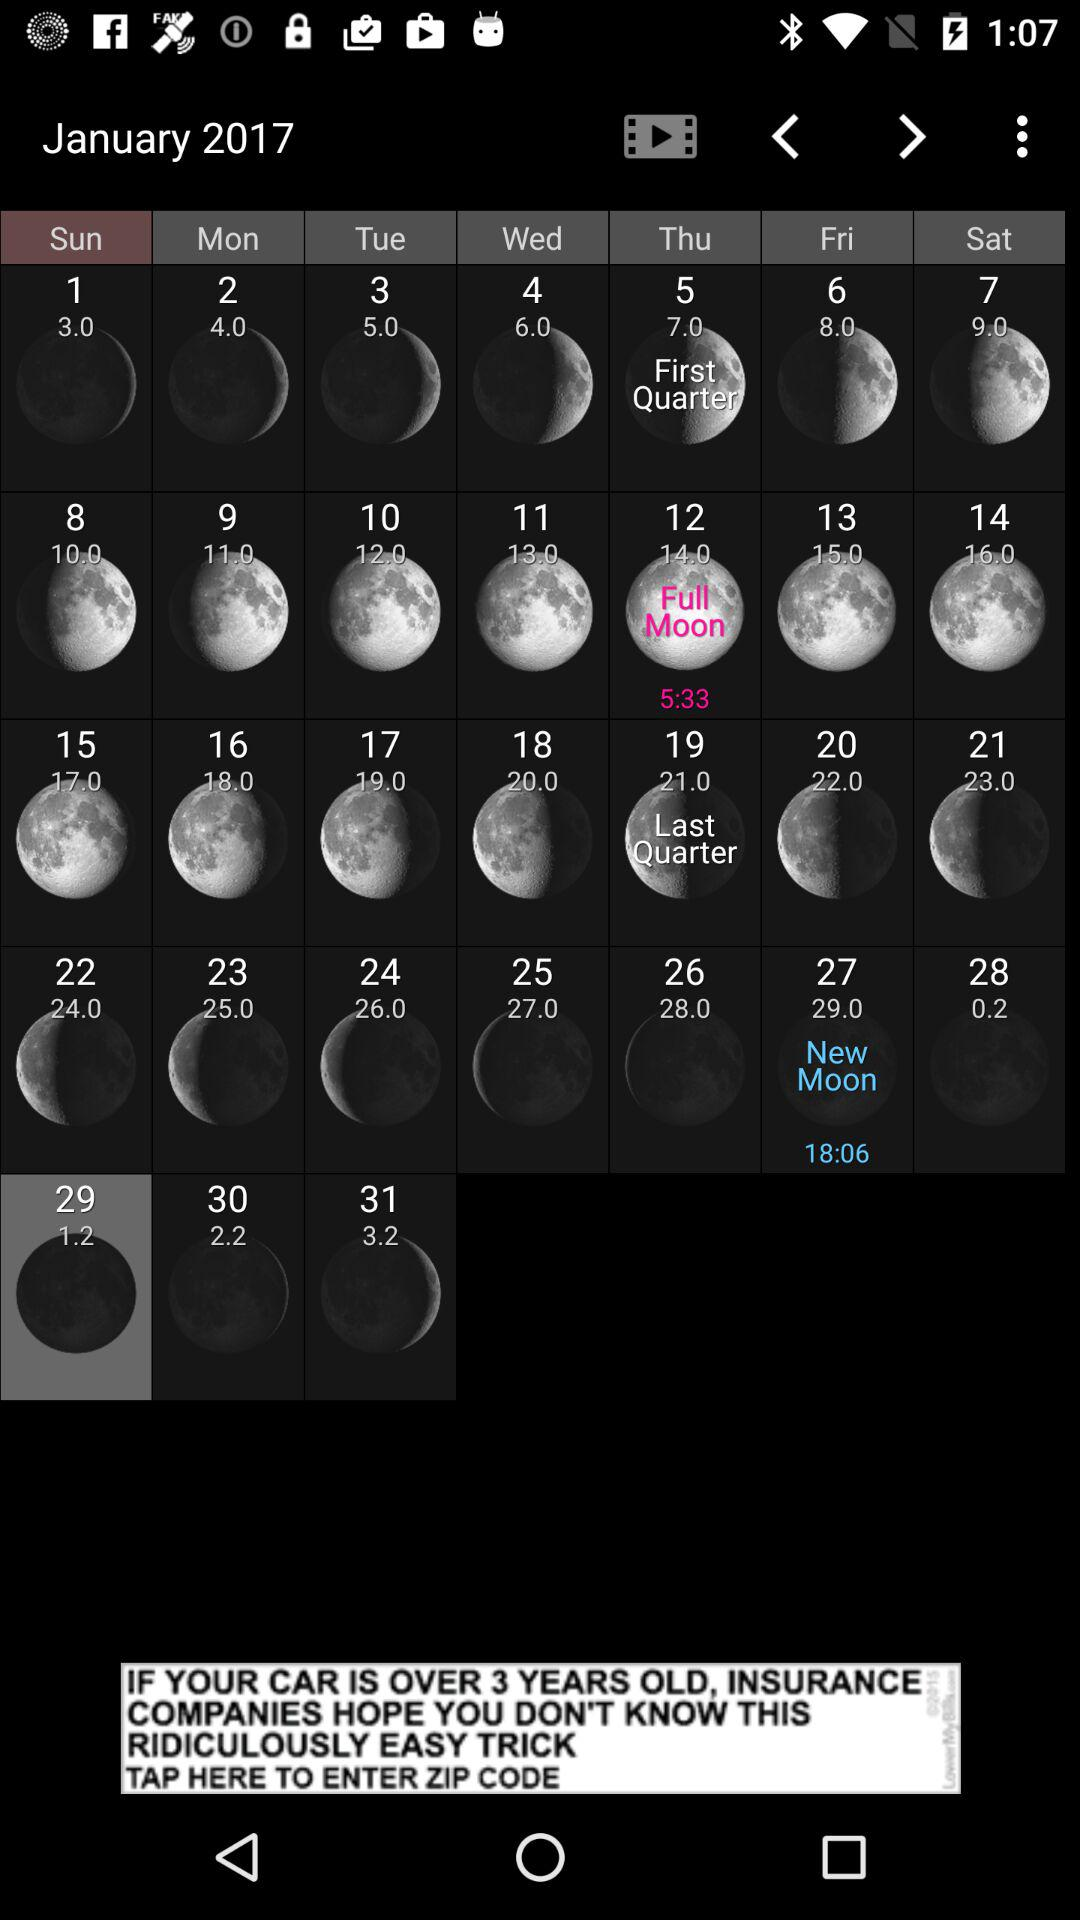What's the date of the "First Quarter Moon"? The date is Thursday, January 5, 2017. 